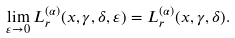<formula> <loc_0><loc_0><loc_500><loc_500>\lim _ { \varepsilon \rightarrow 0 } L ^ { ( \alpha ) } _ { r } ( x , \gamma , \delta , \varepsilon ) = L ^ { ( \alpha ) } _ { r } ( x , \gamma , \delta ) .</formula> 